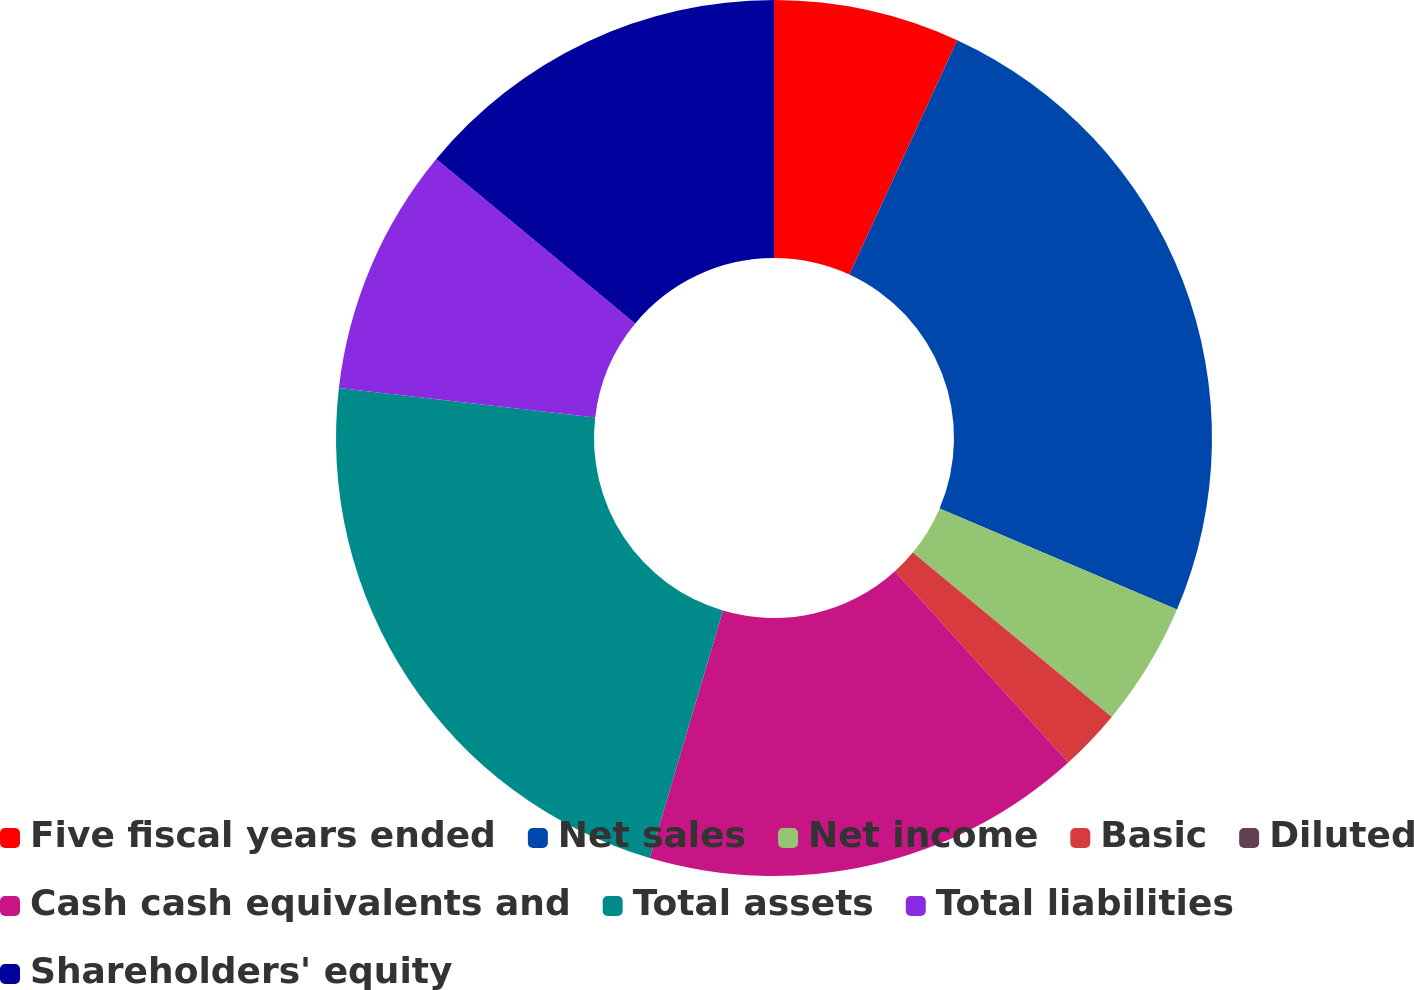<chart> <loc_0><loc_0><loc_500><loc_500><pie_chart><fcel>Five fiscal years ended<fcel>Net sales<fcel>Net income<fcel>Basic<fcel>Diluted<fcel>Cash cash equivalents and<fcel>Total assets<fcel>Total liabilities<fcel>Shareholders' equity<nl><fcel>6.87%<fcel>24.53%<fcel>4.58%<fcel>2.29%<fcel>0.0%<fcel>16.3%<fcel>22.24%<fcel>9.16%<fcel>14.01%<nl></chart> 